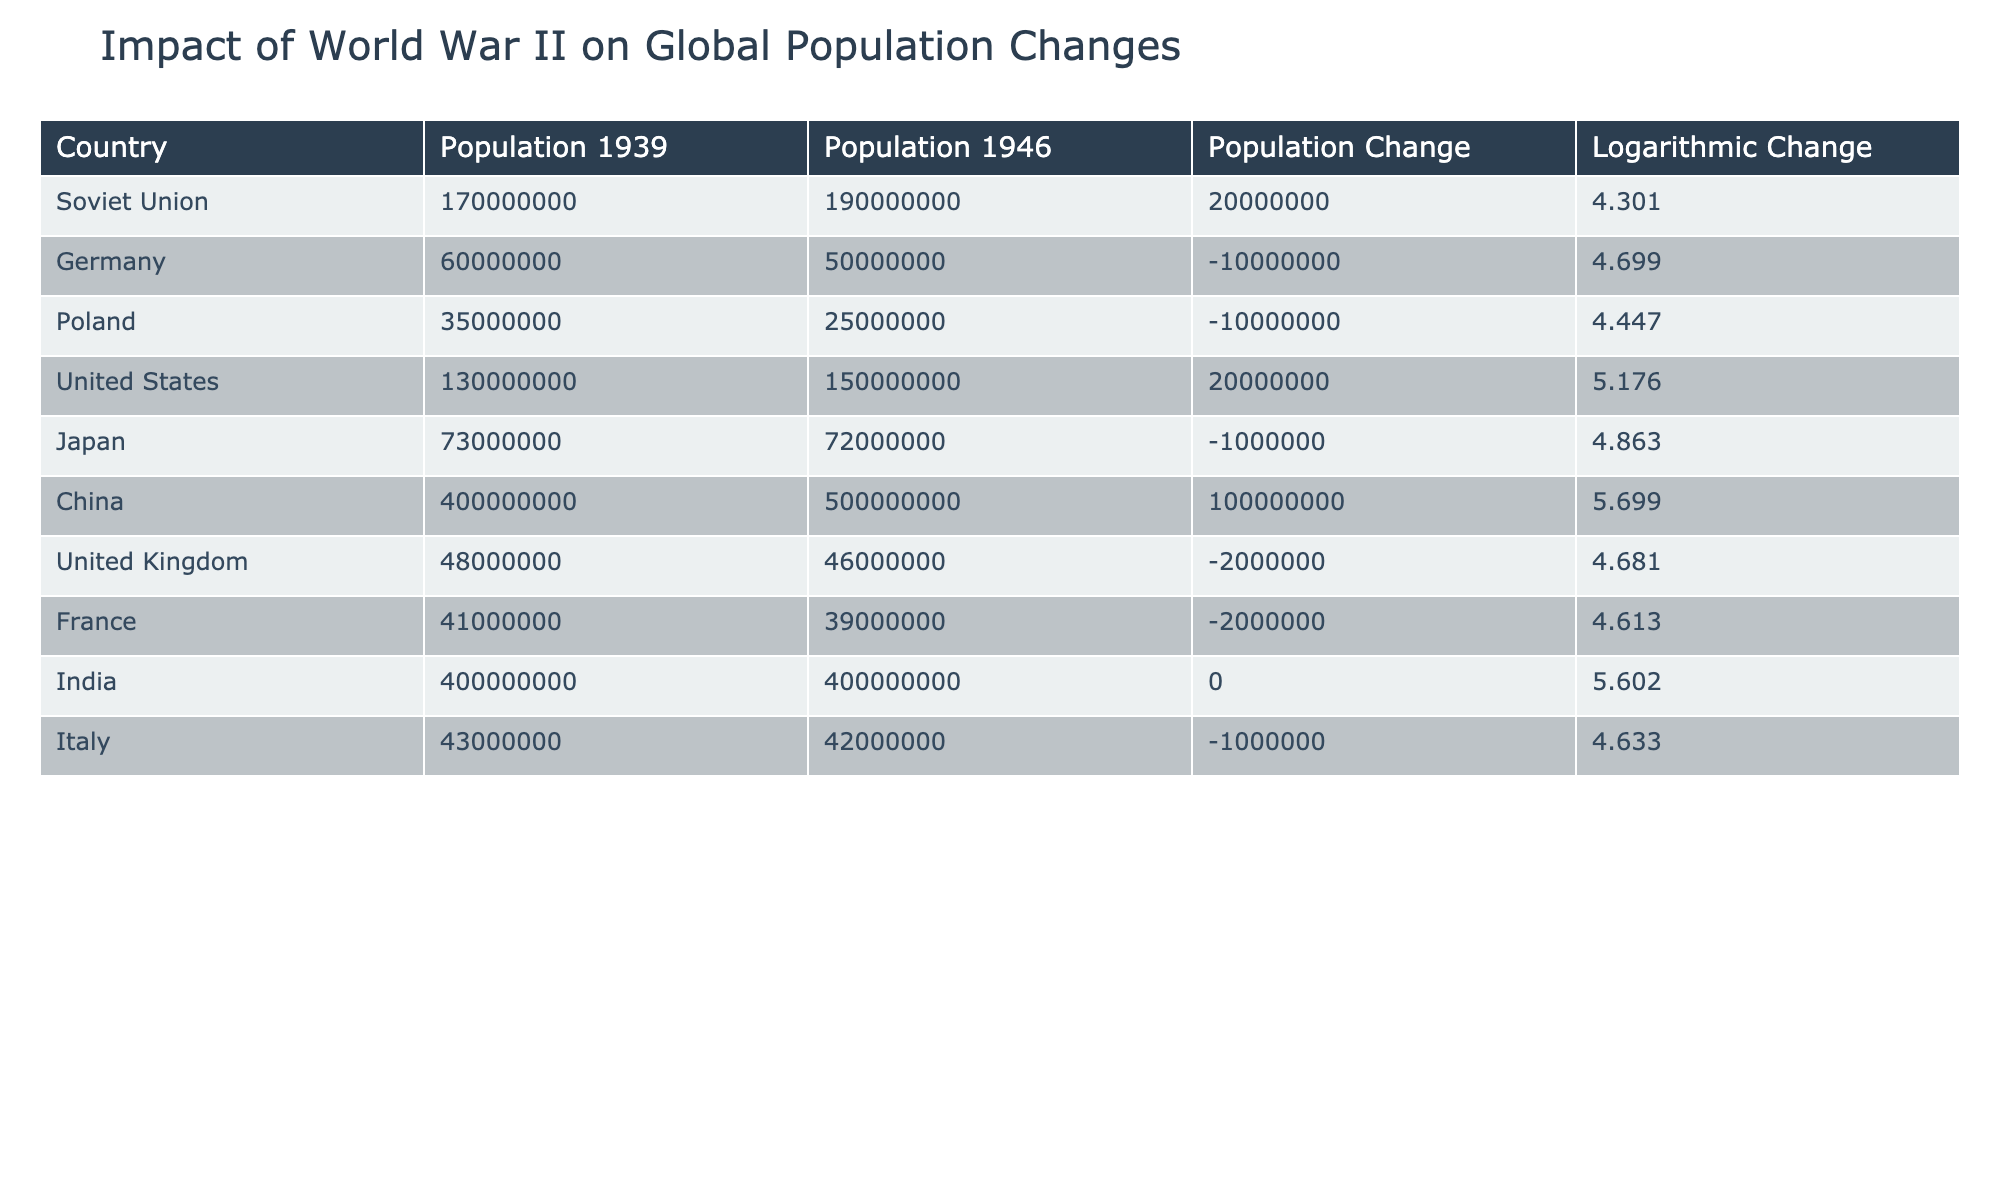What was the population of the Soviet Union in 1946? According to the table, the population of the Soviet Union in 1946 is directly listed under the "Population 1946" column. The value shown is 190000000.
Answer: 190000000 Which country experienced the largest population increase from 1939 to 1946? To determine which country had the largest population increase, we look at the "Population Change" column. The largest positive change is 100000000 for China.
Answer: China True or False: Germany's population decreased from 1939 to 1946. In the table, the "Population Change" for Germany is -10000000, indicating a decrease in population. Since this value is negative, the statement is true.
Answer: True What is the total population change for countries where the population decreased? To find the total population change for countries with a decrease, we sum the values of "Population Change" for Germany, Poland, United Kingdom, France, Japan, and Italy. The sum is (-10000000 - 10000000 - 2000000 - 2000000 - 1000000 - 1000000) = -12000000.
Answer: -12000000 What is the average population of countries that had no change from 1939 to 1946? From the table, only India had no population change, with a population of 400000000. Since there's only one country, the average is simply the population of India itself.
Answer: 400000000 Which country had the highest logarithmic population change and what is its value? Looking at the "Logarithmic Change" column, China has the highest value of 5.699. This is determined by comparing all the logarithmic values in that column.
Answer: 5.699 How many countries had a population change of exactly zero? Referring to the "Population Change" column, we look for the rows with a value of 0. The only country that fits this criterion is India, which indicates there's only one such country.
Answer: 1 What is the difference in logarithmic change between the Soviet Union and the United Kingdom? To find the difference, we take the logarithmic change of the Soviet Union (4.301) and subtract the logarithmic change of the United Kingdom (4.681). The calculation is: 4.301 - 4.681 = -0.38.
Answer: -0.38 How did the population of Japan change in comparison to Germany? Looking at the "Population Change" values for Japan (-1000000) and Germany (-10000000), we see that Japan had a smaller decrease (1000000 is less than 10000000). Thus, Japan's population change was less severe.
Answer: Japan's change was smaller 